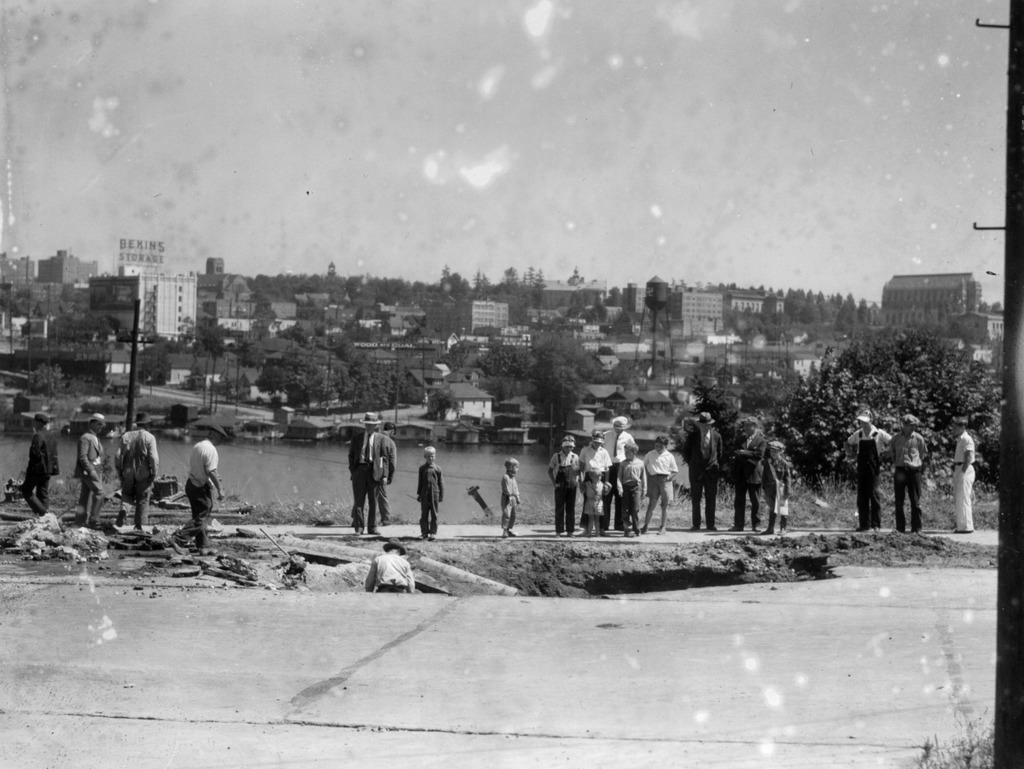What is the color scheme of the image? The image is black and white. What can be seen in the image besides the color scheme? There are people standing, buildings, trees, and poles in the image. How many beggars can be seen in the image? There are no beggars present in the image; it features people, buildings, trees, and poles. What type of crib is visible in the image? There is no crib present in the image. 